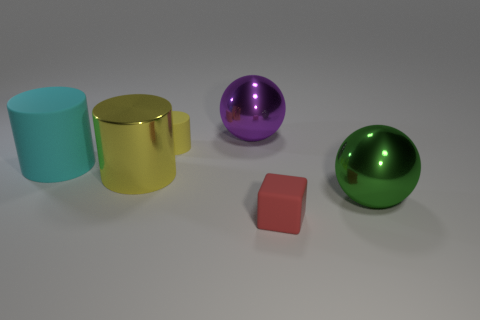Add 3 red matte blocks. How many objects exist? 9 Subtract all blocks. How many objects are left? 5 Add 5 small cubes. How many small cubes exist? 6 Subtract 0 red balls. How many objects are left? 6 Subtract all small brown balls. Subtract all large purple balls. How many objects are left? 5 Add 4 tiny yellow things. How many tiny yellow things are left? 5 